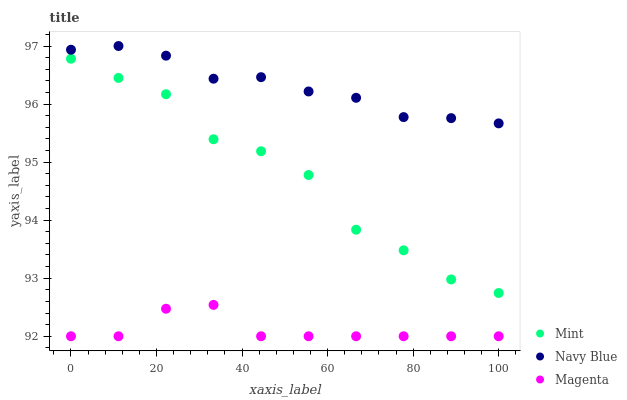Does Magenta have the minimum area under the curve?
Answer yes or no. Yes. Does Navy Blue have the maximum area under the curve?
Answer yes or no. Yes. Does Mint have the minimum area under the curve?
Answer yes or no. No. Does Mint have the maximum area under the curve?
Answer yes or no. No. Is Navy Blue the smoothest?
Answer yes or no. Yes. Is Mint the roughest?
Answer yes or no. Yes. Is Magenta the smoothest?
Answer yes or no. No. Is Magenta the roughest?
Answer yes or no. No. Does Magenta have the lowest value?
Answer yes or no. Yes. Does Mint have the lowest value?
Answer yes or no. No. Does Navy Blue have the highest value?
Answer yes or no. Yes. Does Mint have the highest value?
Answer yes or no. No. Is Magenta less than Navy Blue?
Answer yes or no. Yes. Is Navy Blue greater than Magenta?
Answer yes or no. Yes. Does Magenta intersect Navy Blue?
Answer yes or no. No. 